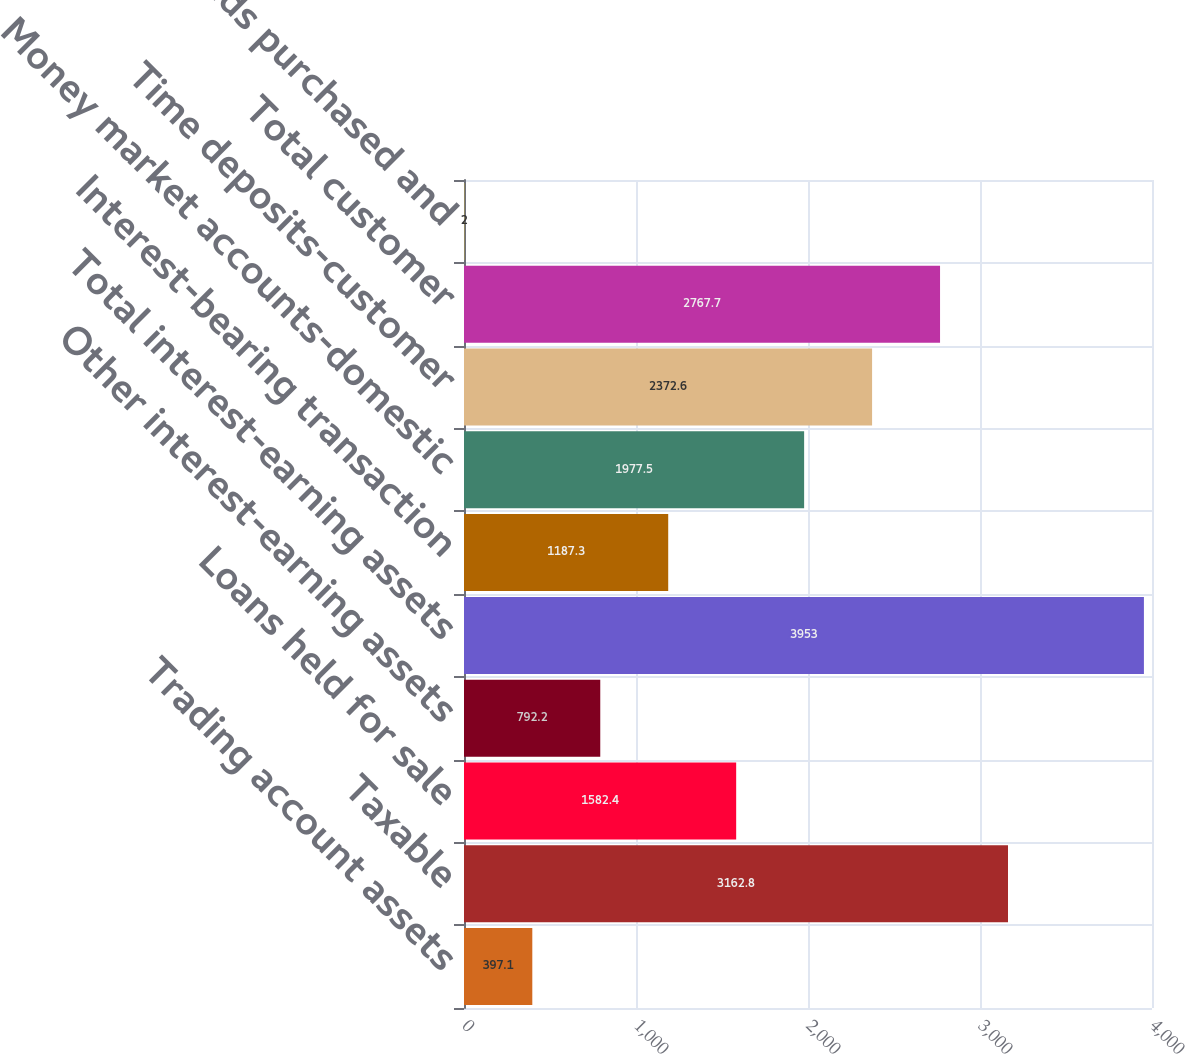<chart> <loc_0><loc_0><loc_500><loc_500><bar_chart><fcel>Trading account assets<fcel>Taxable<fcel>Loans held for sale<fcel>Other interest-earning assets<fcel>Total interest-earning assets<fcel>Interest-bearing transaction<fcel>Money market accounts-domestic<fcel>Time deposits-customer<fcel>Total customer<fcel>Federal funds purchased and<nl><fcel>397.1<fcel>3162.8<fcel>1582.4<fcel>792.2<fcel>3953<fcel>1187.3<fcel>1977.5<fcel>2372.6<fcel>2767.7<fcel>2<nl></chart> 